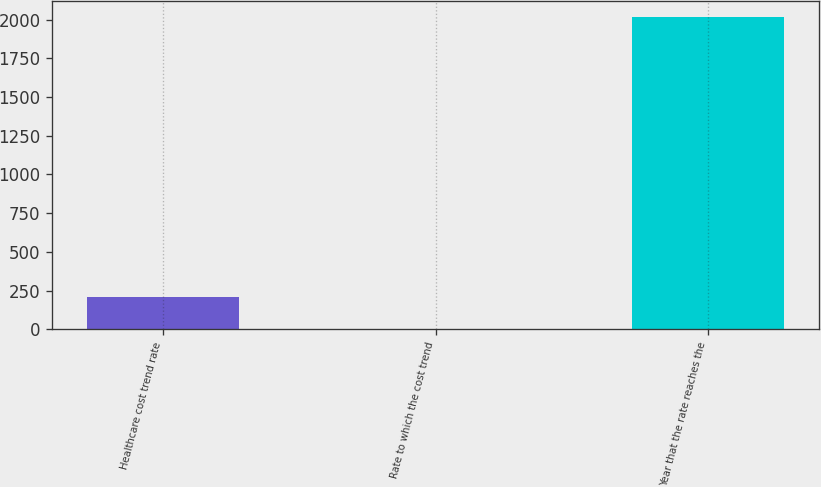Convert chart to OTSL. <chart><loc_0><loc_0><loc_500><loc_500><bar_chart><fcel>Healthcare cost trend rate<fcel>Rate to which the cost trend<fcel>Year that the rate reaches the<nl><fcel>205.85<fcel>4.5<fcel>2018<nl></chart> 